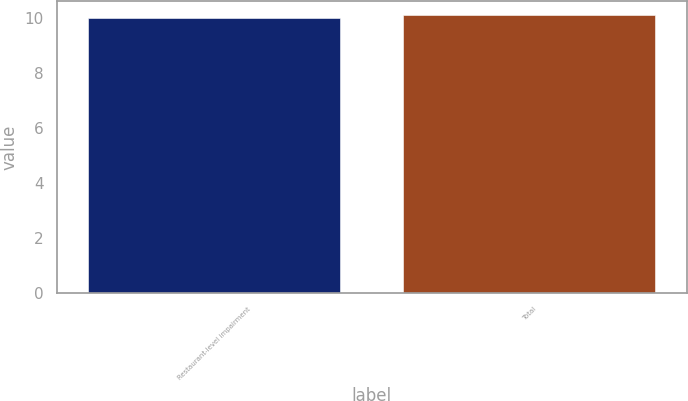Convert chart. <chart><loc_0><loc_0><loc_500><loc_500><bar_chart><fcel>Restaurant-level impairment<fcel>Total<nl><fcel>10<fcel>10.1<nl></chart> 